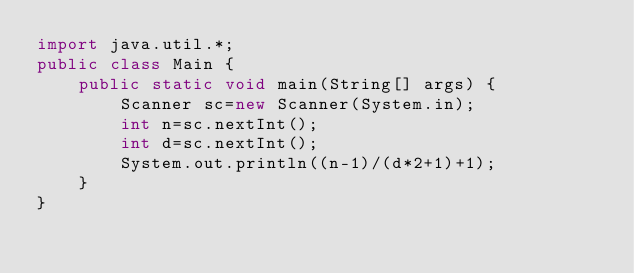Convert code to text. <code><loc_0><loc_0><loc_500><loc_500><_Java_>import java.util.*;
public class Main {
    public static void main(String[] args) {
        Scanner sc=new Scanner(System.in);
        int n=sc.nextInt();
        int d=sc.nextInt();
        System.out.println((n-1)/(d*2+1)+1);
    }
}
</code> 